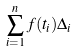Convert formula to latex. <formula><loc_0><loc_0><loc_500><loc_500>\sum _ { i = 1 } ^ { n } f ( t _ { i } ) \Delta _ { i }</formula> 